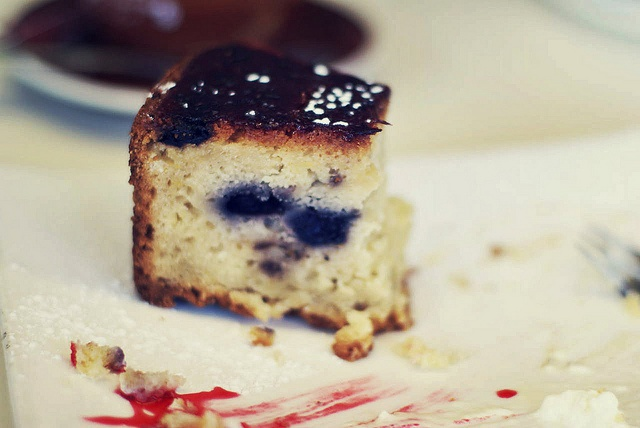Describe the objects in this image and their specific colors. I can see cake in tan and black tones and fork in tan, lightgray, darkgray, and gray tones in this image. 